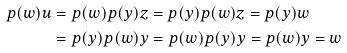<formula> <loc_0><loc_0><loc_500><loc_500>p ( w ) u & = p ( w ) p ( y ) z = p ( y ) p ( w ) z = p ( y ) w \\ & = p ( y ) p ( w ) y = p ( w ) p ( y ) y = p ( w ) y = w</formula> 